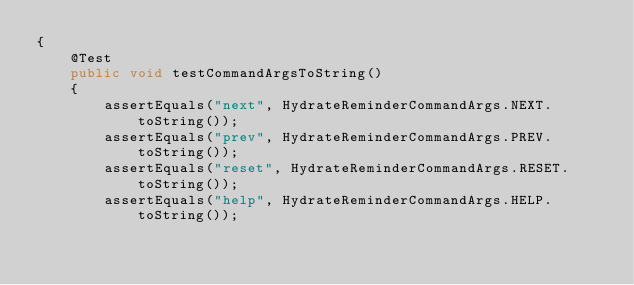Convert code to text. <code><loc_0><loc_0><loc_500><loc_500><_Java_>{
    @Test
    public void testCommandArgsToString()
    {
        assertEquals("next", HydrateReminderCommandArgs.NEXT.toString());
        assertEquals("prev", HydrateReminderCommandArgs.PREV.toString());
        assertEquals("reset", HydrateReminderCommandArgs.RESET.toString());
        assertEquals("help", HydrateReminderCommandArgs.HELP.toString());</code> 